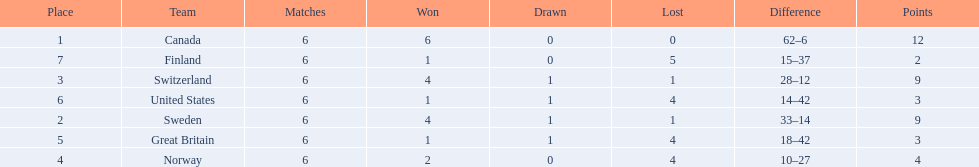What are all the teams? Canada, Sweden, Switzerland, Norway, Great Britain, United States, Finland. What were their points? 12, 9, 9, 4, 3, 3, 2. What about just switzerland and great britain? 9, 3. Now, which of those teams scored higher? Switzerland. 